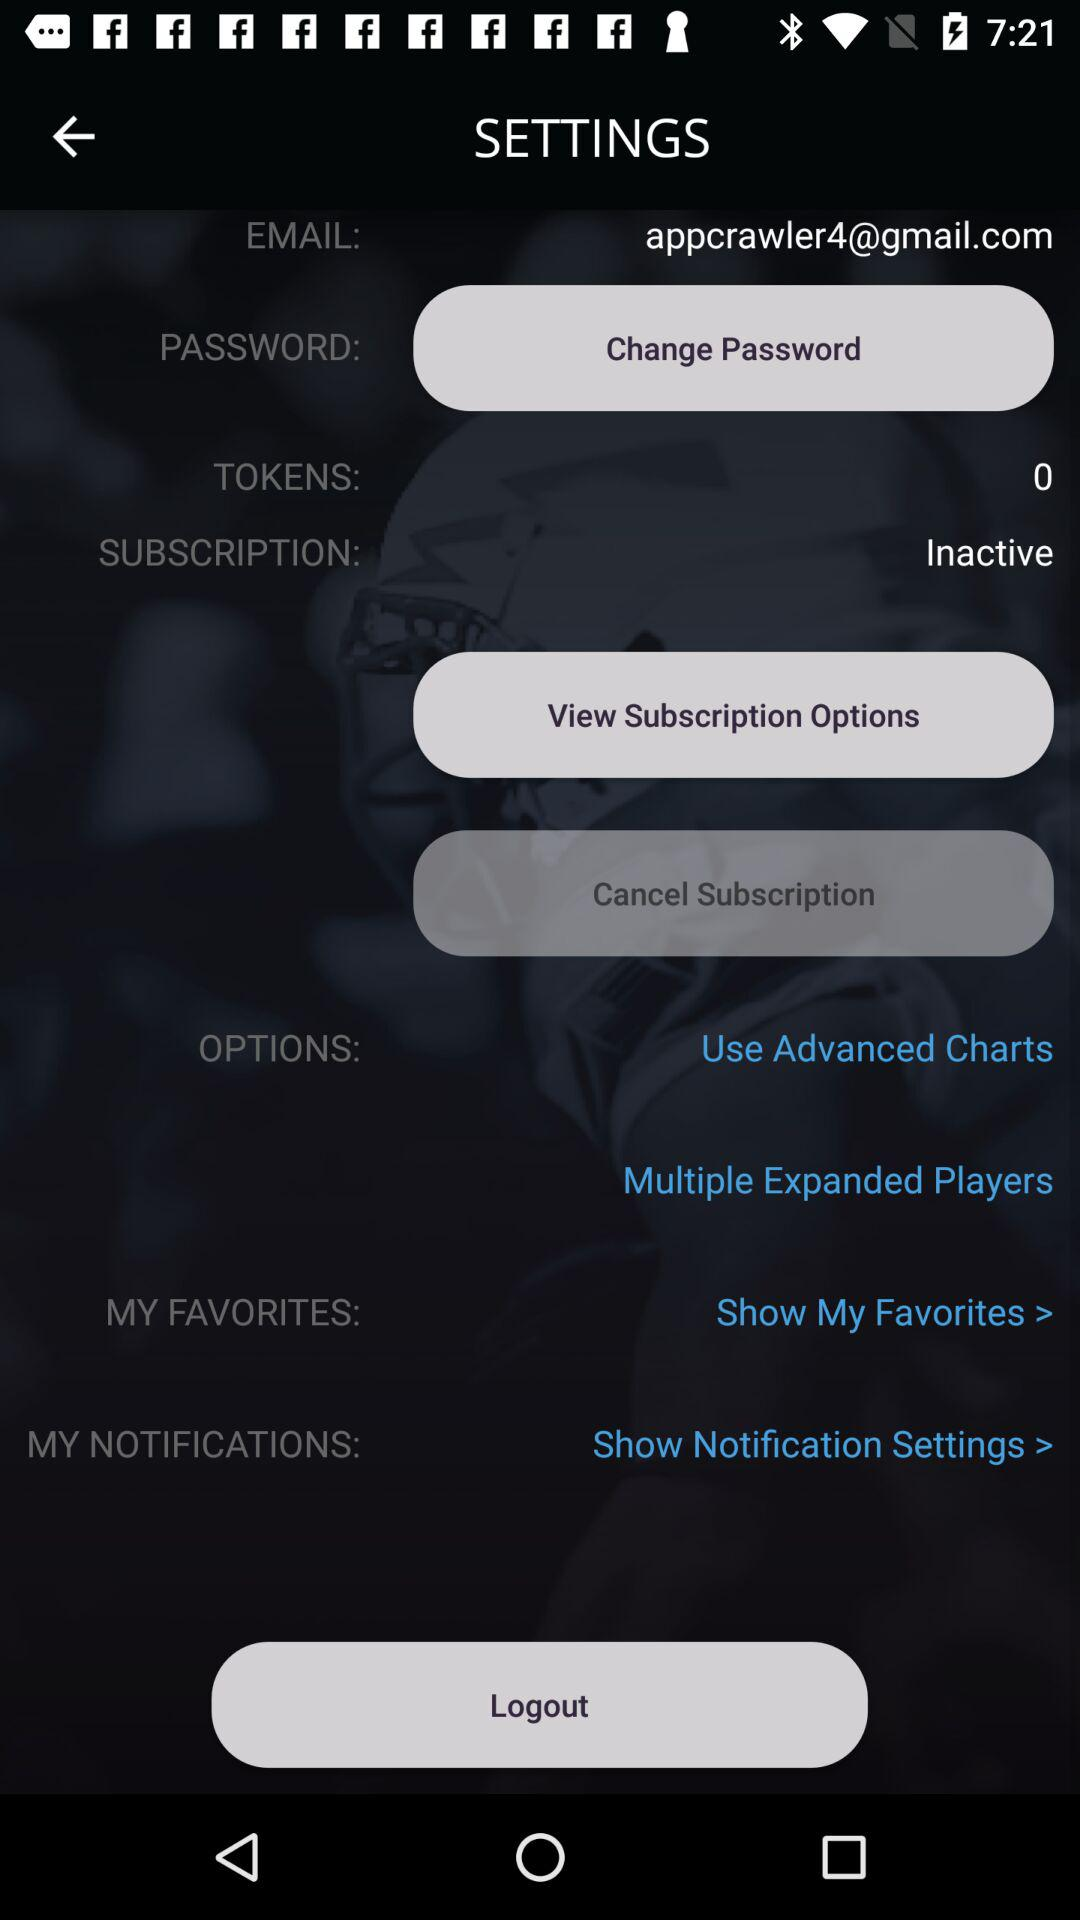What is the number of tokens? The number of tokens is 0. 